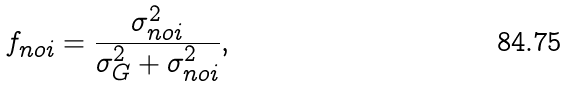Convert formula to latex. <formula><loc_0><loc_0><loc_500><loc_500>f _ { n o i } = \frac { \sigma ^ { 2 } _ { n o i } } { \sigma ^ { 2 } _ { G } + \sigma ^ { 2 } _ { n o i } } ,</formula> 